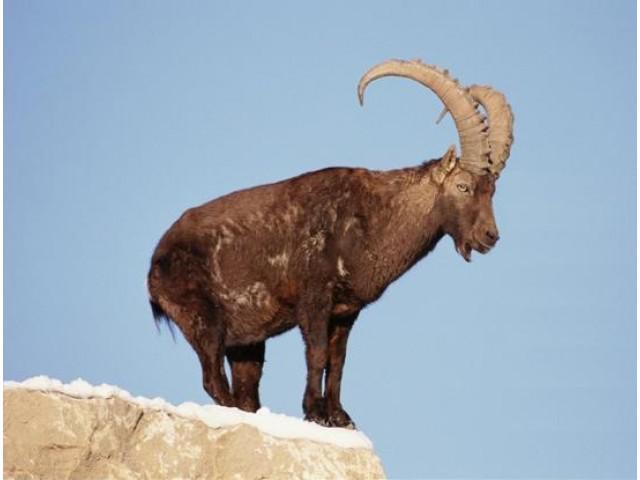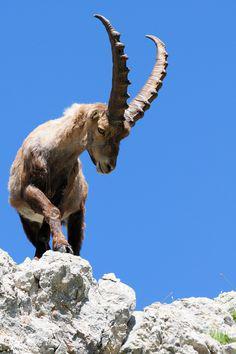The first image is the image on the left, the second image is the image on the right. Evaluate the accuracy of this statement regarding the images: "Each image shows a long-horned animal standing on a rocky peak, and each animal is looking in the same general direction.". Is it true? Answer yes or no. Yes. The first image is the image on the left, the second image is the image on the right. Examine the images to the left and right. Is the description "Both rams are standing on rocky ground." accurate? Answer yes or no. Yes. 